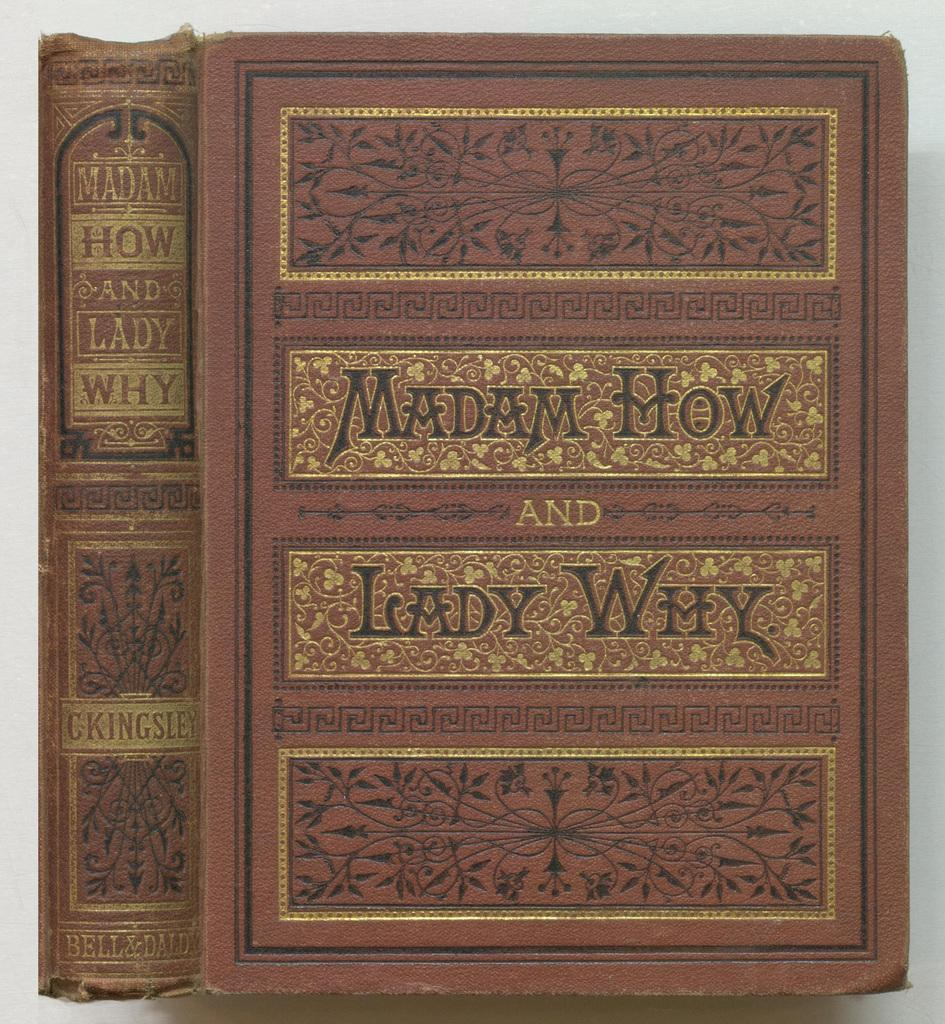Provide a one-sentence caption for the provided image. Fancy looking brown book titled "Madam How And Lady Why". 